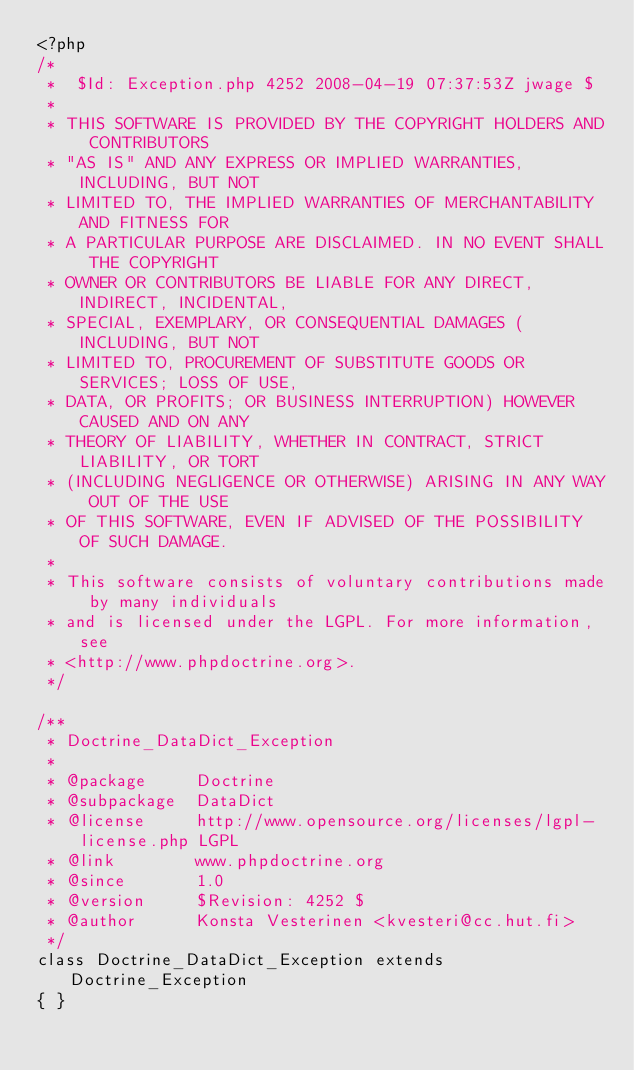<code> <loc_0><loc_0><loc_500><loc_500><_PHP_><?php
/*
 *  $Id: Exception.php 4252 2008-04-19 07:37:53Z jwage $
 *
 * THIS SOFTWARE IS PROVIDED BY THE COPYRIGHT HOLDERS AND CONTRIBUTORS
 * "AS IS" AND ANY EXPRESS OR IMPLIED WARRANTIES, INCLUDING, BUT NOT
 * LIMITED TO, THE IMPLIED WARRANTIES OF MERCHANTABILITY AND FITNESS FOR
 * A PARTICULAR PURPOSE ARE DISCLAIMED. IN NO EVENT SHALL THE COPYRIGHT
 * OWNER OR CONTRIBUTORS BE LIABLE FOR ANY DIRECT, INDIRECT, INCIDENTAL,
 * SPECIAL, EXEMPLARY, OR CONSEQUENTIAL DAMAGES (INCLUDING, BUT NOT
 * LIMITED TO, PROCUREMENT OF SUBSTITUTE GOODS OR SERVICES; LOSS OF USE,
 * DATA, OR PROFITS; OR BUSINESS INTERRUPTION) HOWEVER CAUSED AND ON ANY
 * THEORY OF LIABILITY, WHETHER IN CONTRACT, STRICT LIABILITY, OR TORT
 * (INCLUDING NEGLIGENCE OR OTHERWISE) ARISING IN ANY WAY OUT OF THE USE
 * OF THIS SOFTWARE, EVEN IF ADVISED OF THE POSSIBILITY OF SUCH DAMAGE.
 *
 * This software consists of voluntary contributions made by many individuals
 * and is licensed under the LGPL. For more information, see
 * <http://www.phpdoctrine.org>.
 */

/**
 * Doctrine_DataDict_Exception
 *
 * @package     Doctrine
 * @subpackage  DataDict
 * @license     http://www.opensource.org/licenses/lgpl-license.php LGPL
 * @link        www.phpdoctrine.org
 * @since       1.0
 * @version     $Revision: 4252 $
 * @author      Konsta Vesterinen <kvesteri@cc.hut.fi>
 */
class Doctrine_DataDict_Exception extends Doctrine_Exception
{ }</code> 